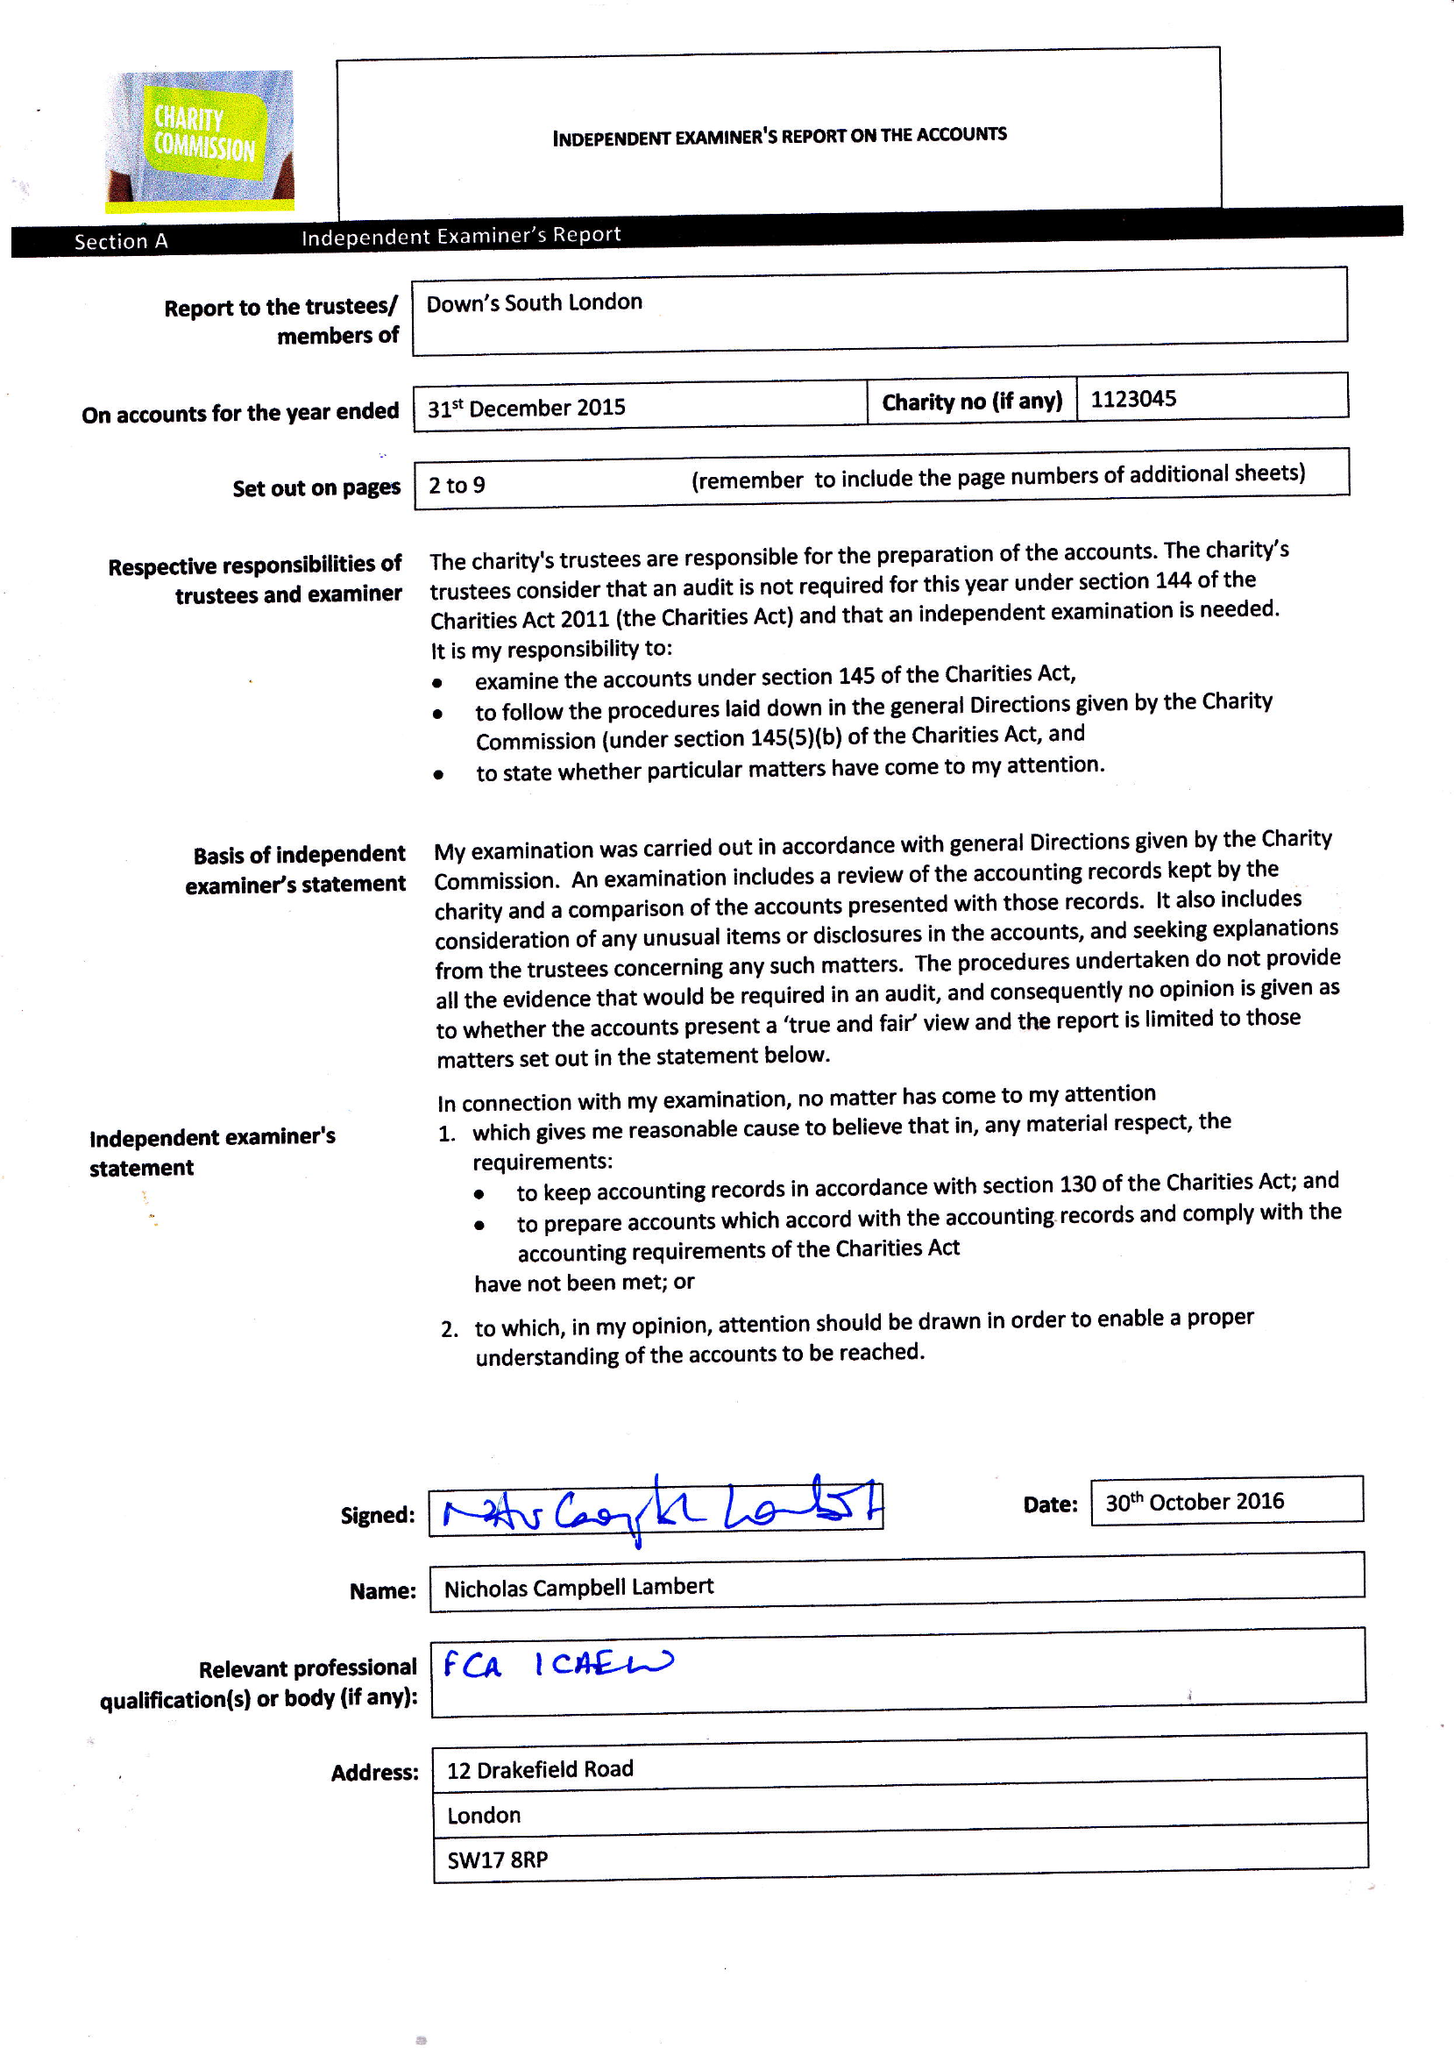What is the value for the charity_number?
Answer the question using a single word or phrase. 1123045 